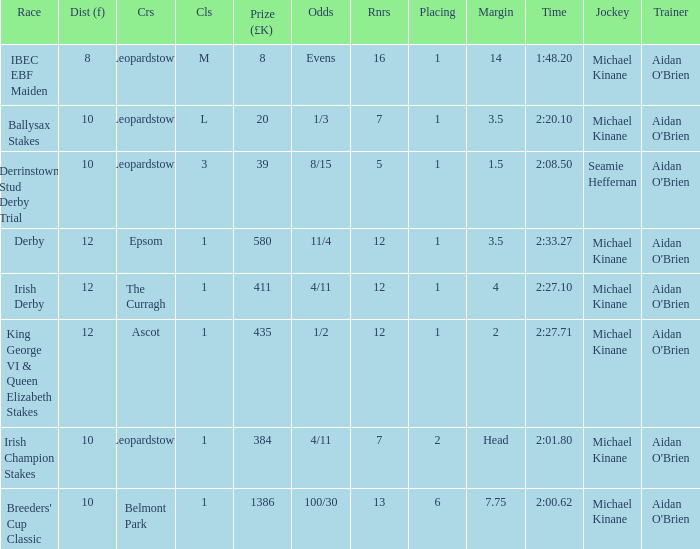Which Margin has a Dist (f) larger than 10, and a Race of king george vi & queen elizabeth stakes? 2.0. 